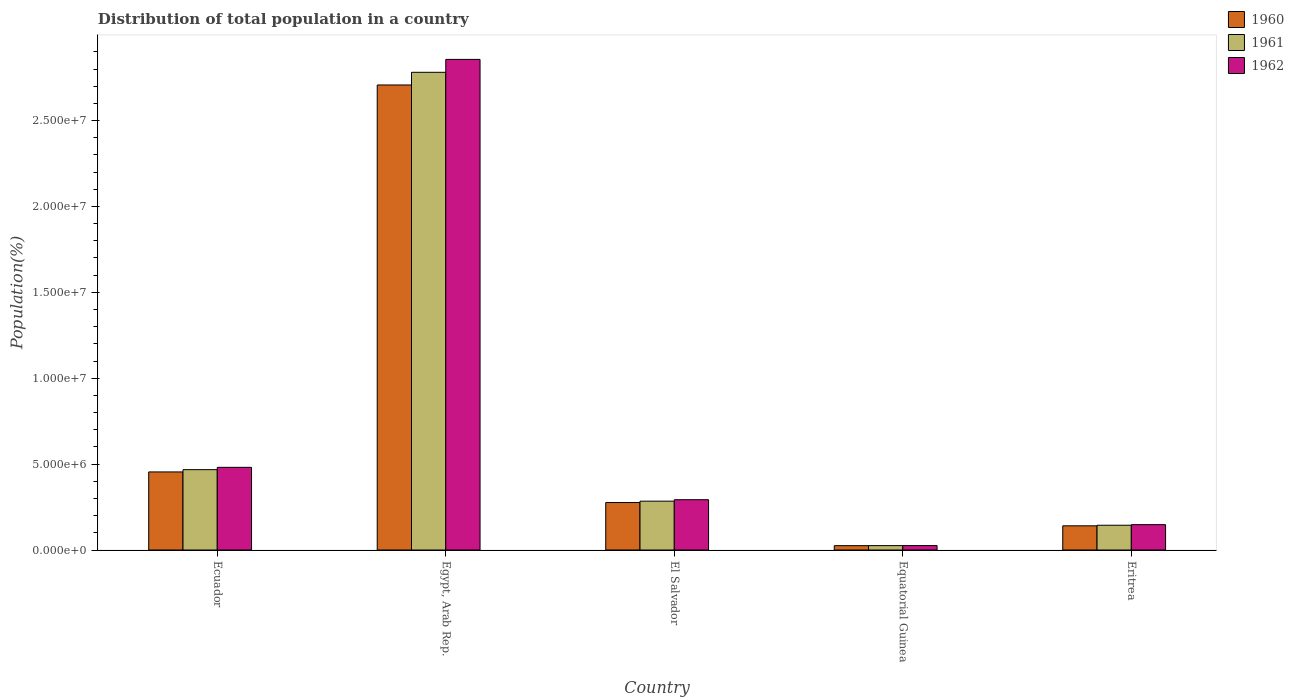Are the number of bars per tick equal to the number of legend labels?
Your response must be concise. Yes. Are the number of bars on each tick of the X-axis equal?
Give a very brief answer. Yes. What is the label of the 2nd group of bars from the left?
Your answer should be compact. Egypt, Arab Rep. In how many cases, is the number of bars for a given country not equal to the number of legend labels?
Your answer should be very brief. 0. What is the population of in 1960 in El Salvador?
Your response must be concise. 2.76e+06. Across all countries, what is the maximum population of in 1962?
Provide a short and direct response. 2.86e+07. Across all countries, what is the minimum population of in 1961?
Ensure brevity in your answer.  2.55e+05. In which country was the population of in 1960 maximum?
Offer a very short reply. Egypt, Arab Rep. In which country was the population of in 1961 minimum?
Give a very brief answer. Equatorial Guinea. What is the total population of in 1960 in the graph?
Your answer should be compact. 3.60e+07. What is the difference between the population of in 1960 in Egypt, Arab Rep. and that in Equatorial Guinea?
Your response must be concise. 2.68e+07. What is the difference between the population of in 1962 in Equatorial Guinea and the population of in 1961 in Eritrea?
Ensure brevity in your answer.  -1.18e+06. What is the average population of in 1962 per country?
Your answer should be very brief. 7.61e+06. What is the difference between the population of of/in 1962 and population of of/in 1960 in Ecuador?
Provide a succinct answer. 2.67e+05. In how many countries, is the population of in 1960 greater than 6000000 %?
Provide a short and direct response. 1. What is the ratio of the population of in 1961 in Ecuador to that in Eritrea?
Offer a very short reply. 3.24. Is the population of in 1962 in Ecuador less than that in Equatorial Guinea?
Offer a terse response. No. Is the difference between the population of in 1962 in El Salvador and Equatorial Guinea greater than the difference between the population of in 1960 in El Salvador and Equatorial Guinea?
Provide a short and direct response. Yes. What is the difference between the highest and the second highest population of in 1960?
Your response must be concise. -1.78e+06. What is the difference between the highest and the lowest population of in 1961?
Offer a terse response. 2.76e+07. Is the sum of the population of in 1962 in El Salvador and Eritrea greater than the maximum population of in 1961 across all countries?
Provide a succinct answer. No. What does the 1st bar from the left in Egypt, Arab Rep. represents?
Your response must be concise. 1960. What does the 2nd bar from the right in Eritrea represents?
Keep it short and to the point. 1961. Is it the case that in every country, the sum of the population of in 1960 and population of in 1962 is greater than the population of in 1961?
Ensure brevity in your answer.  Yes. Are all the bars in the graph horizontal?
Your response must be concise. No. Are the values on the major ticks of Y-axis written in scientific E-notation?
Make the answer very short. Yes. Does the graph contain grids?
Keep it short and to the point. No. How are the legend labels stacked?
Make the answer very short. Vertical. What is the title of the graph?
Provide a succinct answer. Distribution of total population in a country. What is the label or title of the X-axis?
Keep it short and to the point. Country. What is the label or title of the Y-axis?
Ensure brevity in your answer.  Population(%). What is the Population(%) of 1960 in Ecuador?
Offer a very short reply. 4.55e+06. What is the Population(%) of 1961 in Ecuador?
Offer a terse response. 4.68e+06. What is the Population(%) of 1962 in Ecuador?
Offer a terse response. 4.81e+06. What is the Population(%) in 1960 in Egypt, Arab Rep.?
Give a very brief answer. 2.71e+07. What is the Population(%) of 1961 in Egypt, Arab Rep.?
Offer a very short reply. 2.78e+07. What is the Population(%) in 1962 in Egypt, Arab Rep.?
Keep it short and to the point. 2.86e+07. What is the Population(%) of 1960 in El Salvador?
Ensure brevity in your answer.  2.76e+06. What is the Population(%) in 1961 in El Salvador?
Provide a short and direct response. 2.84e+06. What is the Population(%) of 1962 in El Salvador?
Keep it short and to the point. 2.93e+06. What is the Population(%) of 1960 in Equatorial Guinea?
Your response must be concise. 2.52e+05. What is the Population(%) in 1961 in Equatorial Guinea?
Offer a terse response. 2.55e+05. What is the Population(%) of 1962 in Equatorial Guinea?
Provide a short and direct response. 2.58e+05. What is the Population(%) of 1960 in Eritrea?
Ensure brevity in your answer.  1.41e+06. What is the Population(%) in 1961 in Eritrea?
Offer a very short reply. 1.44e+06. What is the Population(%) of 1962 in Eritrea?
Your answer should be compact. 1.48e+06. Across all countries, what is the maximum Population(%) in 1960?
Keep it short and to the point. 2.71e+07. Across all countries, what is the maximum Population(%) in 1961?
Ensure brevity in your answer.  2.78e+07. Across all countries, what is the maximum Population(%) of 1962?
Give a very brief answer. 2.86e+07. Across all countries, what is the minimum Population(%) of 1960?
Ensure brevity in your answer.  2.52e+05. Across all countries, what is the minimum Population(%) in 1961?
Your answer should be compact. 2.55e+05. Across all countries, what is the minimum Population(%) in 1962?
Make the answer very short. 2.58e+05. What is the total Population(%) in 1960 in the graph?
Provide a short and direct response. 3.60e+07. What is the total Population(%) in 1961 in the graph?
Ensure brevity in your answer.  3.70e+07. What is the total Population(%) of 1962 in the graph?
Give a very brief answer. 3.80e+07. What is the difference between the Population(%) of 1960 in Ecuador and that in Egypt, Arab Rep.?
Offer a terse response. -2.25e+07. What is the difference between the Population(%) in 1961 in Ecuador and that in Egypt, Arab Rep.?
Your answer should be compact. -2.31e+07. What is the difference between the Population(%) in 1962 in Ecuador and that in Egypt, Arab Rep.?
Your answer should be compact. -2.37e+07. What is the difference between the Population(%) of 1960 in Ecuador and that in El Salvador?
Your response must be concise. 1.78e+06. What is the difference between the Population(%) of 1961 in Ecuador and that in El Salvador?
Offer a very short reply. 1.83e+06. What is the difference between the Population(%) of 1962 in Ecuador and that in El Salvador?
Your response must be concise. 1.89e+06. What is the difference between the Population(%) of 1960 in Ecuador and that in Equatorial Guinea?
Keep it short and to the point. 4.29e+06. What is the difference between the Population(%) of 1961 in Ecuador and that in Equatorial Guinea?
Provide a short and direct response. 4.42e+06. What is the difference between the Population(%) of 1962 in Ecuador and that in Equatorial Guinea?
Offer a very short reply. 4.55e+06. What is the difference between the Population(%) in 1960 in Ecuador and that in Eritrea?
Keep it short and to the point. 3.14e+06. What is the difference between the Population(%) of 1961 in Ecuador and that in Eritrea?
Give a very brief answer. 3.24e+06. What is the difference between the Population(%) in 1962 in Ecuador and that in Eritrea?
Your response must be concise. 3.34e+06. What is the difference between the Population(%) in 1960 in Egypt, Arab Rep. and that in El Salvador?
Keep it short and to the point. 2.43e+07. What is the difference between the Population(%) in 1961 in Egypt, Arab Rep. and that in El Salvador?
Your answer should be compact. 2.50e+07. What is the difference between the Population(%) of 1962 in Egypt, Arab Rep. and that in El Salvador?
Your response must be concise. 2.56e+07. What is the difference between the Population(%) of 1960 in Egypt, Arab Rep. and that in Equatorial Guinea?
Keep it short and to the point. 2.68e+07. What is the difference between the Population(%) in 1961 in Egypt, Arab Rep. and that in Equatorial Guinea?
Give a very brief answer. 2.76e+07. What is the difference between the Population(%) in 1962 in Egypt, Arab Rep. and that in Equatorial Guinea?
Your answer should be very brief. 2.83e+07. What is the difference between the Population(%) in 1960 in Egypt, Arab Rep. and that in Eritrea?
Offer a very short reply. 2.57e+07. What is the difference between the Population(%) of 1961 in Egypt, Arab Rep. and that in Eritrea?
Provide a succinct answer. 2.64e+07. What is the difference between the Population(%) of 1962 in Egypt, Arab Rep. and that in Eritrea?
Provide a succinct answer. 2.71e+07. What is the difference between the Population(%) in 1960 in El Salvador and that in Equatorial Guinea?
Provide a short and direct response. 2.51e+06. What is the difference between the Population(%) of 1961 in El Salvador and that in Equatorial Guinea?
Offer a very short reply. 2.59e+06. What is the difference between the Population(%) in 1962 in El Salvador and that in Equatorial Guinea?
Offer a very short reply. 2.67e+06. What is the difference between the Population(%) of 1960 in El Salvador and that in Eritrea?
Provide a succinct answer. 1.36e+06. What is the difference between the Population(%) in 1961 in El Salvador and that in Eritrea?
Provide a succinct answer. 1.40e+06. What is the difference between the Population(%) of 1962 in El Salvador and that in Eritrea?
Provide a succinct answer. 1.45e+06. What is the difference between the Population(%) in 1960 in Equatorial Guinea and that in Eritrea?
Your response must be concise. -1.16e+06. What is the difference between the Population(%) of 1961 in Equatorial Guinea and that in Eritrea?
Keep it short and to the point. -1.19e+06. What is the difference between the Population(%) of 1962 in Equatorial Guinea and that in Eritrea?
Offer a terse response. -1.22e+06. What is the difference between the Population(%) of 1960 in Ecuador and the Population(%) of 1961 in Egypt, Arab Rep.?
Offer a terse response. -2.33e+07. What is the difference between the Population(%) of 1960 in Ecuador and the Population(%) of 1962 in Egypt, Arab Rep.?
Provide a succinct answer. -2.40e+07. What is the difference between the Population(%) of 1961 in Ecuador and the Population(%) of 1962 in Egypt, Arab Rep.?
Provide a short and direct response. -2.39e+07. What is the difference between the Population(%) of 1960 in Ecuador and the Population(%) of 1961 in El Salvador?
Your answer should be very brief. 1.70e+06. What is the difference between the Population(%) of 1960 in Ecuador and the Population(%) of 1962 in El Salvador?
Offer a very short reply. 1.62e+06. What is the difference between the Population(%) in 1961 in Ecuador and the Population(%) in 1962 in El Salvador?
Offer a very short reply. 1.75e+06. What is the difference between the Population(%) of 1960 in Ecuador and the Population(%) of 1961 in Equatorial Guinea?
Your response must be concise. 4.29e+06. What is the difference between the Population(%) in 1960 in Ecuador and the Population(%) in 1962 in Equatorial Guinea?
Keep it short and to the point. 4.29e+06. What is the difference between the Population(%) in 1961 in Ecuador and the Population(%) in 1962 in Equatorial Guinea?
Provide a succinct answer. 4.42e+06. What is the difference between the Population(%) in 1960 in Ecuador and the Population(%) in 1961 in Eritrea?
Provide a succinct answer. 3.10e+06. What is the difference between the Population(%) of 1960 in Ecuador and the Population(%) of 1962 in Eritrea?
Make the answer very short. 3.07e+06. What is the difference between the Population(%) of 1961 in Ecuador and the Population(%) of 1962 in Eritrea?
Offer a very short reply. 3.20e+06. What is the difference between the Population(%) in 1960 in Egypt, Arab Rep. and the Population(%) in 1961 in El Salvador?
Keep it short and to the point. 2.42e+07. What is the difference between the Population(%) in 1960 in Egypt, Arab Rep. and the Population(%) in 1962 in El Salvador?
Provide a succinct answer. 2.41e+07. What is the difference between the Population(%) in 1961 in Egypt, Arab Rep. and the Population(%) in 1962 in El Salvador?
Your answer should be very brief. 2.49e+07. What is the difference between the Population(%) in 1960 in Egypt, Arab Rep. and the Population(%) in 1961 in Equatorial Guinea?
Offer a terse response. 2.68e+07. What is the difference between the Population(%) of 1960 in Egypt, Arab Rep. and the Population(%) of 1962 in Equatorial Guinea?
Give a very brief answer. 2.68e+07. What is the difference between the Population(%) in 1961 in Egypt, Arab Rep. and the Population(%) in 1962 in Equatorial Guinea?
Offer a terse response. 2.76e+07. What is the difference between the Population(%) in 1960 in Egypt, Arab Rep. and the Population(%) in 1961 in Eritrea?
Offer a very short reply. 2.56e+07. What is the difference between the Population(%) in 1960 in Egypt, Arab Rep. and the Population(%) in 1962 in Eritrea?
Provide a succinct answer. 2.56e+07. What is the difference between the Population(%) of 1961 in Egypt, Arab Rep. and the Population(%) of 1962 in Eritrea?
Ensure brevity in your answer.  2.63e+07. What is the difference between the Population(%) in 1960 in El Salvador and the Population(%) in 1961 in Equatorial Guinea?
Offer a terse response. 2.51e+06. What is the difference between the Population(%) in 1960 in El Salvador and the Population(%) in 1962 in Equatorial Guinea?
Offer a terse response. 2.50e+06. What is the difference between the Population(%) of 1961 in El Salvador and the Population(%) of 1962 in Equatorial Guinea?
Provide a short and direct response. 2.59e+06. What is the difference between the Population(%) of 1960 in El Salvador and the Population(%) of 1961 in Eritrea?
Ensure brevity in your answer.  1.32e+06. What is the difference between the Population(%) of 1960 in El Salvador and the Population(%) of 1962 in Eritrea?
Offer a terse response. 1.29e+06. What is the difference between the Population(%) in 1961 in El Salvador and the Population(%) in 1962 in Eritrea?
Offer a terse response. 1.37e+06. What is the difference between the Population(%) of 1960 in Equatorial Guinea and the Population(%) of 1961 in Eritrea?
Your response must be concise. -1.19e+06. What is the difference between the Population(%) of 1960 in Equatorial Guinea and the Population(%) of 1962 in Eritrea?
Provide a short and direct response. -1.22e+06. What is the difference between the Population(%) of 1961 in Equatorial Guinea and the Population(%) of 1962 in Eritrea?
Give a very brief answer. -1.22e+06. What is the average Population(%) in 1960 per country?
Provide a short and direct response. 7.21e+06. What is the average Population(%) of 1961 per country?
Your answer should be compact. 7.41e+06. What is the average Population(%) in 1962 per country?
Provide a succinct answer. 7.61e+06. What is the difference between the Population(%) in 1960 and Population(%) in 1961 in Ecuador?
Your response must be concise. -1.31e+05. What is the difference between the Population(%) of 1960 and Population(%) of 1962 in Ecuador?
Provide a short and direct response. -2.67e+05. What is the difference between the Population(%) in 1961 and Population(%) in 1962 in Ecuador?
Ensure brevity in your answer.  -1.36e+05. What is the difference between the Population(%) in 1960 and Population(%) in 1961 in Egypt, Arab Rep.?
Provide a succinct answer. -7.38e+05. What is the difference between the Population(%) of 1960 and Population(%) of 1962 in Egypt, Arab Rep.?
Give a very brief answer. -1.49e+06. What is the difference between the Population(%) in 1961 and Population(%) in 1962 in Egypt, Arab Rep.?
Keep it short and to the point. -7.51e+05. What is the difference between the Population(%) in 1960 and Population(%) in 1961 in El Salvador?
Your answer should be compact. -8.03e+04. What is the difference between the Population(%) of 1960 and Population(%) of 1962 in El Salvador?
Ensure brevity in your answer.  -1.65e+05. What is the difference between the Population(%) in 1961 and Population(%) in 1962 in El Salvador?
Provide a succinct answer. -8.46e+04. What is the difference between the Population(%) of 1960 and Population(%) of 1961 in Equatorial Guinea?
Provide a succinct answer. -2985. What is the difference between the Population(%) of 1960 and Population(%) of 1962 in Equatorial Guinea?
Keep it short and to the point. -5825. What is the difference between the Population(%) in 1961 and Population(%) in 1962 in Equatorial Guinea?
Keep it short and to the point. -2840. What is the difference between the Population(%) in 1960 and Population(%) in 1961 in Eritrea?
Offer a very short reply. -3.37e+04. What is the difference between the Population(%) of 1960 and Population(%) of 1962 in Eritrea?
Offer a very short reply. -6.87e+04. What is the difference between the Population(%) of 1961 and Population(%) of 1962 in Eritrea?
Offer a terse response. -3.50e+04. What is the ratio of the Population(%) in 1960 in Ecuador to that in Egypt, Arab Rep.?
Give a very brief answer. 0.17. What is the ratio of the Population(%) of 1961 in Ecuador to that in Egypt, Arab Rep.?
Provide a short and direct response. 0.17. What is the ratio of the Population(%) of 1962 in Ecuador to that in Egypt, Arab Rep.?
Provide a succinct answer. 0.17. What is the ratio of the Population(%) in 1960 in Ecuador to that in El Salvador?
Provide a short and direct response. 1.65. What is the ratio of the Population(%) of 1961 in Ecuador to that in El Salvador?
Your response must be concise. 1.64. What is the ratio of the Population(%) in 1962 in Ecuador to that in El Salvador?
Provide a succinct answer. 1.64. What is the ratio of the Population(%) in 1960 in Ecuador to that in Equatorial Guinea?
Provide a short and direct response. 18.03. What is the ratio of the Population(%) of 1961 in Ecuador to that in Equatorial Guinea?
Offer a very short reply. 18.33. What is the ratio of the Population(%) of 1962 in Ecuador to that in Equatorial Guinea?
Your answer should be very brief. 18.66. What is the ratio of the Population(%) of 1960 in Ecuador to that in Eritrea?
Offer a terse response. 3.23. What is the ratio of the Population(%) in 1961 in Ecuador to that in Eritrea?
Make the answer very short. 3.24. What is the ratio of the Population(%) of 1962 in Ecuador to that in Eritrea?
Make the answer very short. 3.26. What is the ratio of the Population(%) in 1960 in Egypt, Arab Rep. to that in El Salvador?
Provide a succinct answer. 9.8. What is the ratio of the Population(%) of 1961 in Egypt, Arab Rep. to that in El Salvador?
Your answer should be compact. 9.78. What is the ratio of the Population(%) in 1962 in Egypt, Arab Rep. to that in El Salvador?
Offer a terse response. 9.75. What is the ratio of the Population(%) of 1960 in Egypt, Arab Rep. to that in Equatorial Guinea?
Your response must be concise. 107.38. What is the ratio of the Population(%) of 1961 in Egypt, Arab Rep. to that in Equatorial Guinea?
Keep it short and to the point. 109.02. What is the ratio of the Population(%) of 1962 in Egypt, Arab Rep. to that in Equatorial Guinea?
Provide a succinct answer. 110.73. What is the ratio of the Population(%) in 1960 in Egypt, Arab Rep. to that in Eritrea?
Provide a succinct answer. 19.23. What is the ratio of the Population(%) in 1961 in Egypt, Arab Rep. to that in Eritrea?
Make the answer very short. 19.3. What is the ratio of the Population(%) of 1962 in Egypt, Arab Rep. to that in Eritrea?
Provide a succinct answer. 19.35. What is the ratio of the Population(%) of 1960 in El Salvador to that in Equatorial Guinea?
Make the answer very short. 10.96. What is the ratio of the Population(%) of 1961 in El Salvador to that in Equatorial Guinea?
Your response must be concise. 11.15. What is the ratio of the Population(%) of 1962 in El Salvador to that in Equatorial Guinea?
Offer a very short reply. 11.35. What is the ratio of the Population(%) in 1960 in El Salvador to that in Eritrea?
Provide a short and direct response. 1.96. What is the ratio of the Population(%) in 1961 in El Salvador to that in Eritrea?
Keep it short and to the point. 1.97. What is the ratio of the Population(%) in 1962 in El Salvador to that in Eritrea?
Provide a short and direct response. 1.98. What is the ratio of the Population(%) of 1960 in Equatorial Guinea to that in Eritrea?
Make the answer very short. 0.18. What is the ratio of the Population(%) of 1961 in Equatorial Guinea to that in Eritrea?
Provide a succinct answer. 0.18. What is the ratio of the Population(%) of 1962 in Equatorial Guinea to that in Eritrea?
Offer a very short reply. 0.17. What is the difference between the highest and the second highest Population(%) of 1960?
Ensure brevity in your answer.  2.25e+07. What is the difference between the highest and the second highest Population(%) of 1961?
Your response must be concise. 2.31e+07. What is the difference between the highest and the second highest Population(%) of 1962?
Offer a terse response. 2.37e+07. What is the difference between the highest and the lowest Population(%) of 1960?
Ensure brevity in your answer.  2.68e+07. What is the difference between the highest and the lowest Population(%) in 1961?
Provide a short and direct response. 2.76e+07. What is the difference between the highest and the lowest Population(%) of 1962?
Your answer should be very brief. 2.83e+07. 